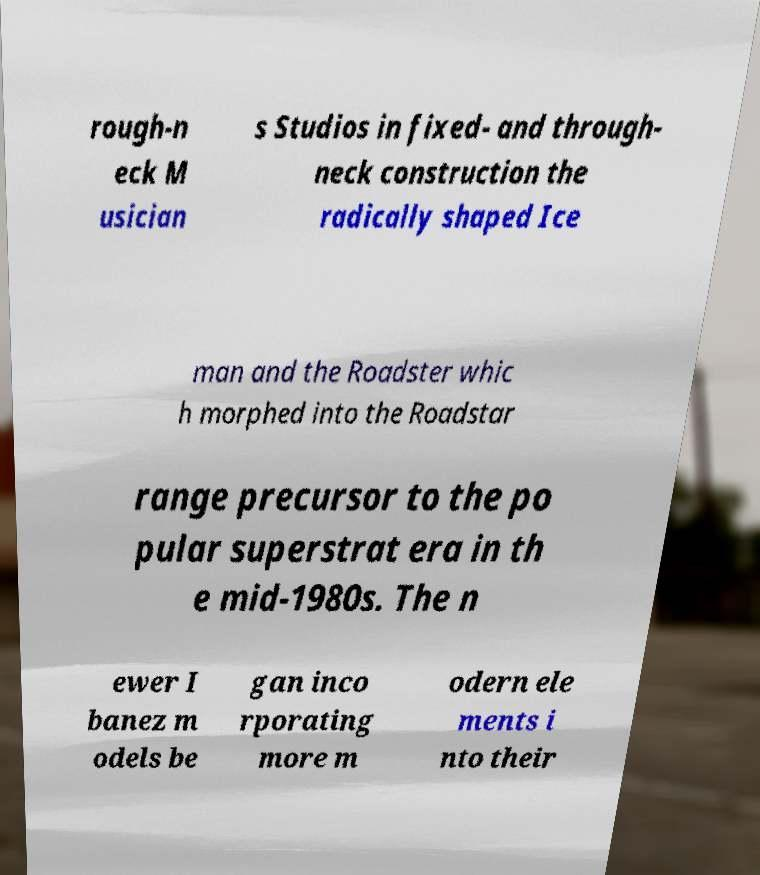Please read and relay the text visible in this image. What does it say? rough-n eck M usician s Studios in fixed- and through- neck construction the radically shaped Ice man and the Roadster whic h morphed into the Roadstar range precursor to the po pular superstrat era in th e mid-1980s. The n ewer I banez m odels be gan inco rporating more m odern ele ments i nto their 